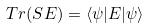<formula> <loc_0><loc_0><loc_500><loc_500>T r ( S E ) = \langle \psi | E | \psi \rangle</formula> 